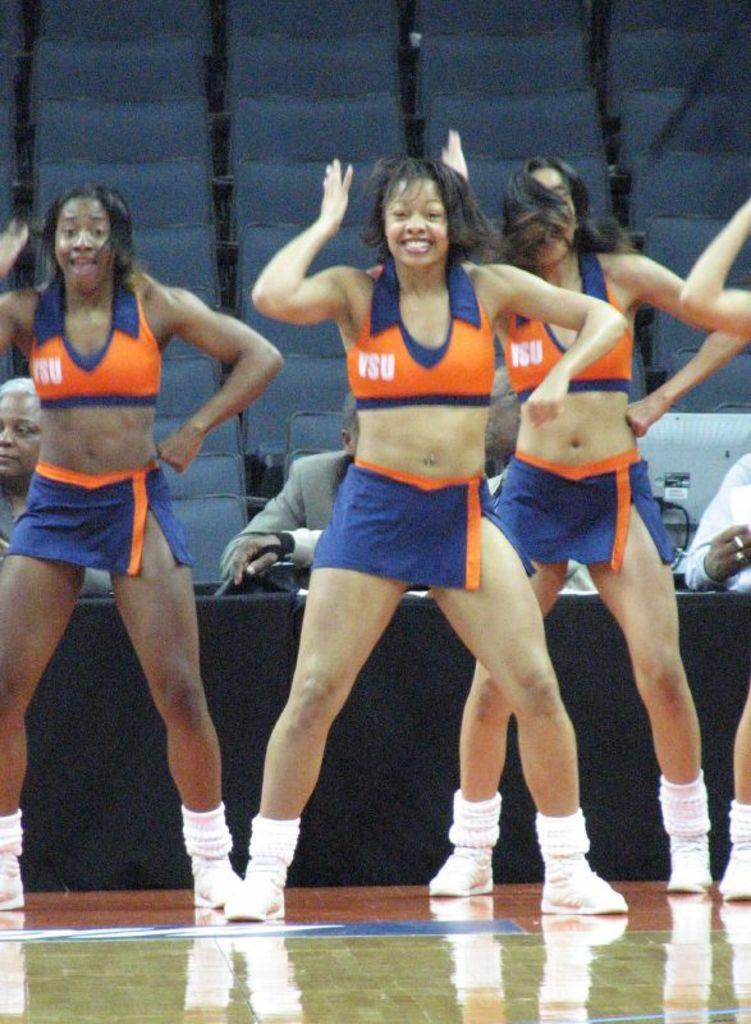<image>
Summarize the visual content of the image. Several cheerleaders wearing uniforms inscripted with VSU are performing. 